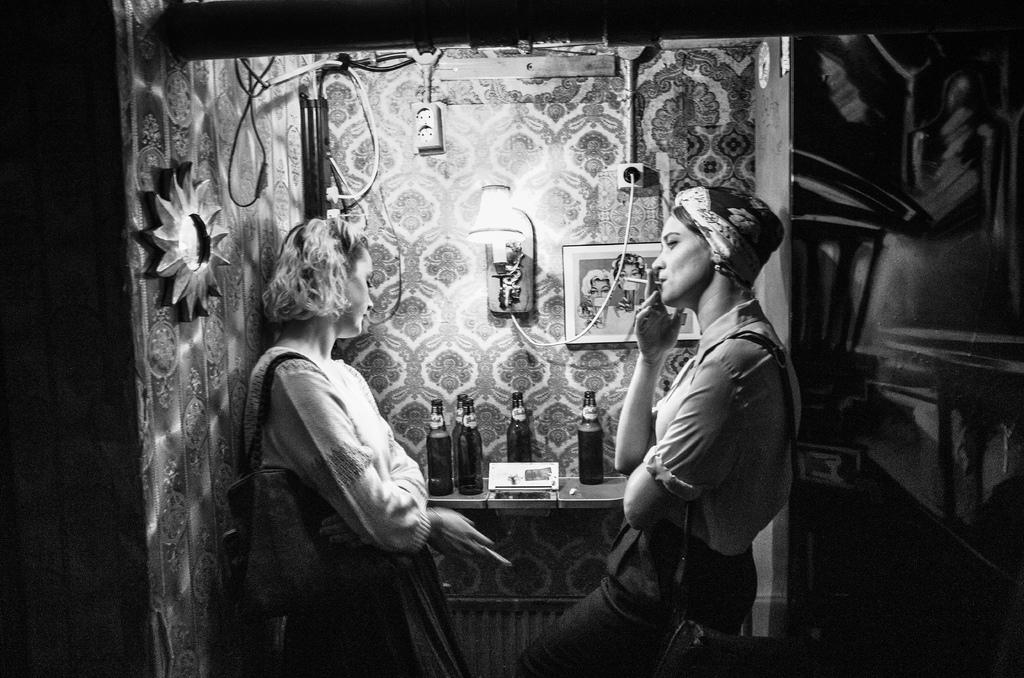How many women are in the image? There are two women in the image. What are the women holding in the image? The women are holding cigarettes. What else can be seen in the image besides the women? There are bottles, a light, a frame on the wall, and a black and white photograph in the frame. Can you see any animals from the zoo in the image? No, there are no animals from the zoo present in the image. Is there any snow visible in the image? No, there is no snow visible in the image. 